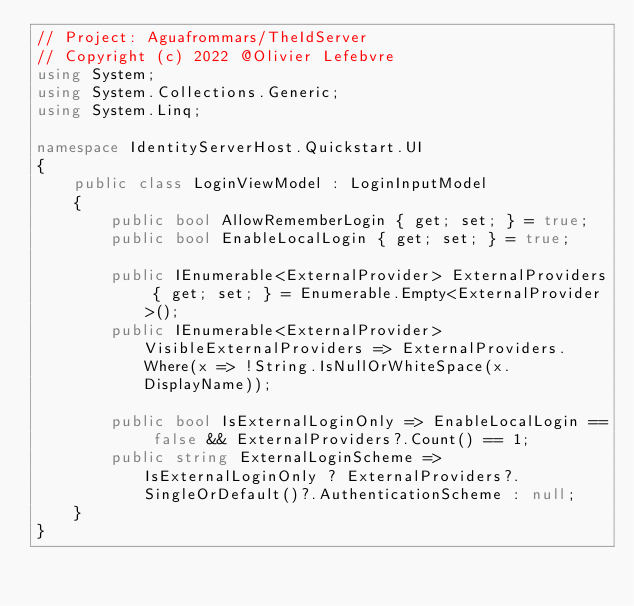Convert code to text. <code><loc_0><loc_0><loc_500><loc_500><_C#_>// Project: Aguafrommars/TheIdServer
// Copyright (c) 2022 @Olivier Lefebvre
using System;
using System.Collections.Generic;
using System.Linq;

namespace IdentityServerHost.Quickstart.UI
{
    public class LoginViewModel : LoginInputModel
    {
        public bool AllowRememberLogin { get; set; } = true;
        public bool EnableLocalLogin { get; set; } = true;

        public IEnumerable<ExternalProvider> ExternalProviders { get; set; } = Enumerable.Empty<ExternalProvider>();
        public IEnumerable<ExternalProvider> VisibleExternalProviders => ExternalProviders.Where(x => !String.IsNullOrWhiteSpace(x.DisplayName));

        public bool IsExternalLoginOnly => EnableLocalLogin == false && ExternalProviders?.Count() == 1;
        public string ExternalLoginScheme => IsExternalLoginOnly ? ExternalProviders?.SingleOrDefault()?.AuthenticationScheme : null;
    }
}</code> 